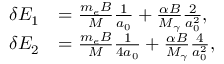Convert formula to latex. <formula><loc_0><loc_0><loc_500><loc_500>\begin{array} { r l } { \delta E _ { 1 } } & { = \frac { m _ { e } B } { M } \frac { 1 } { a _ { 0 } } + \frac { \alpha B } { M _ { \gamma } } \frac { 2 } { a _ { 0 } ^ { 2 } } , } \\ { \delta E _ { 2 } } & { = \frac { m _ { e } B } { M } \frac { 1 } { 4 a _ { 0 } } + \frac { \alpha B } { M _ { \gamma } } \frac { 4 } { a _ { 0 } ^ { 2 } } , } \end{array}</formula> 